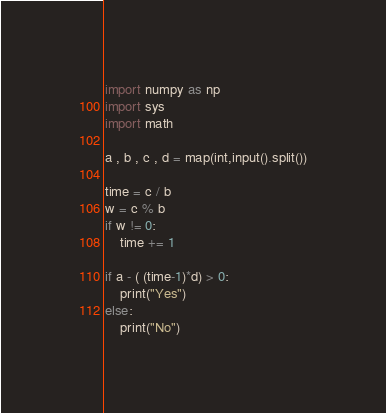<code> <loc_0><loc_0><loc_500><loc_500><_Python_>import numpy as np
import sys
import math

a , b , c , d = map(int,input().split())

time = c / b
w = c % b 
if w != 0:
    time += 1

if a - ( (time-1)*d) > 0:
    print("Yes")
else:
    print("No")
</code> 